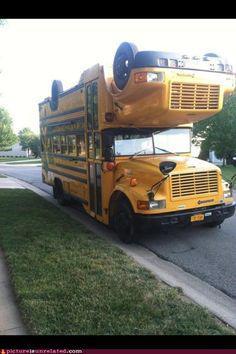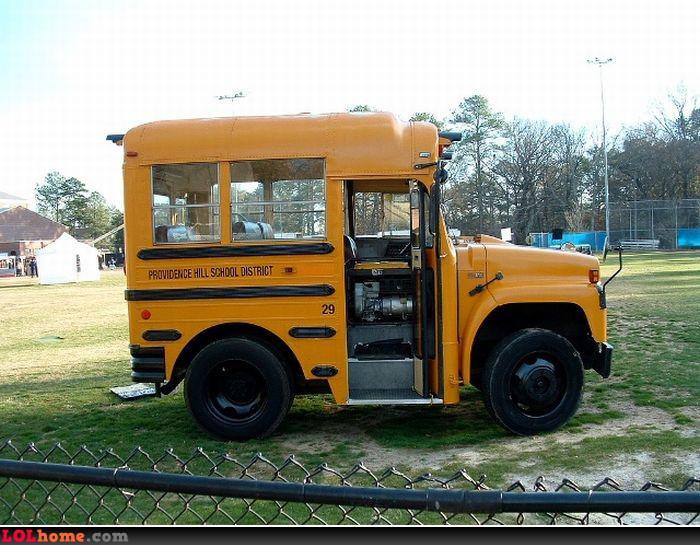The first image is the image on the left, the second image is the image on the right. Assess this claim about the two images: "One bus has wheels on its roof.". Correct or not? Answer yes or no. Yes. 